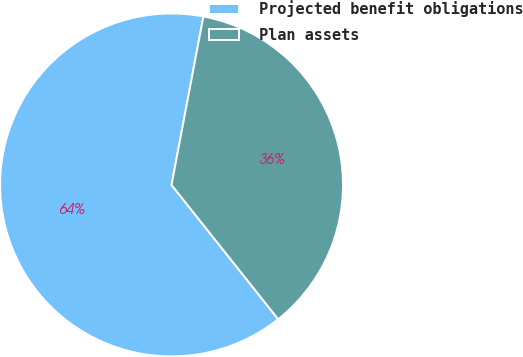Convert chart. <chart><loc_0><loc_0><loc_500><loc_500><pie_chart><fcel>Projected benefit obligations<fcel>Plan assets<nl><fcel>63.66%<fcel>36.34%<nl></chart> 